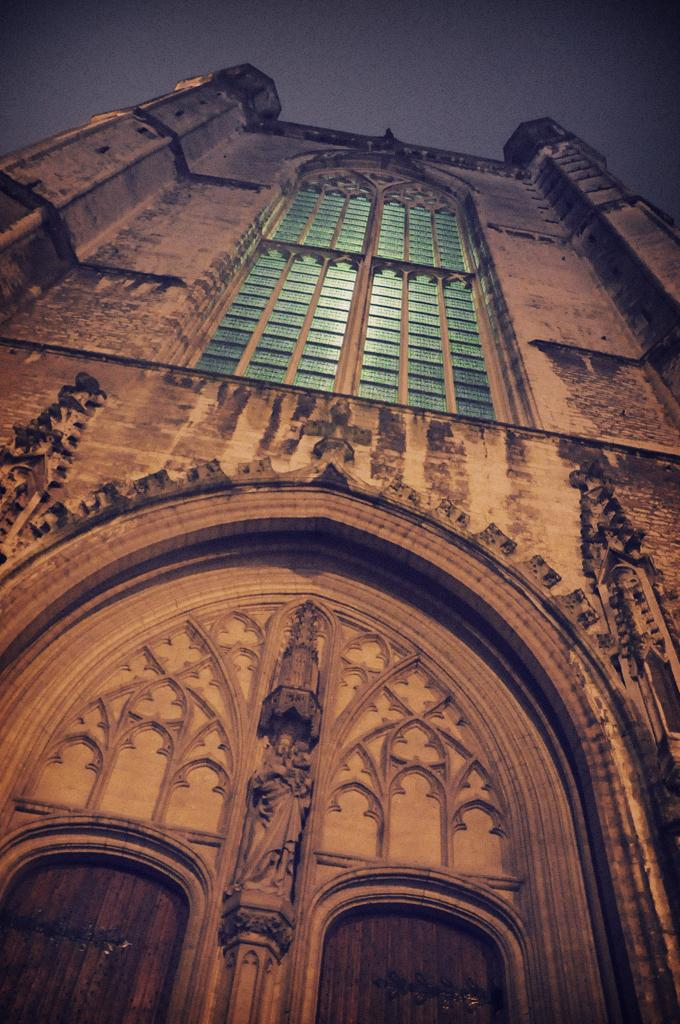What type of structure is visible in the image? There is a building in the image. What are the main features of the building? The building has walls, pillars, and an arch-shaped door. Can you describe the door in more detail? The arch-shaped door has sculptures on it. Are there any openings in the building for light and ventilation? Yes, there are windows in the building. What type of guitar can be seen being played in the image? There is no guitar present in the image; it features a building with an arch-shaped door and sculptures. Is there any snow or indication of winter in the image? There is no mention of snow or winter in the image; it only shows a building with specific architectural features. 